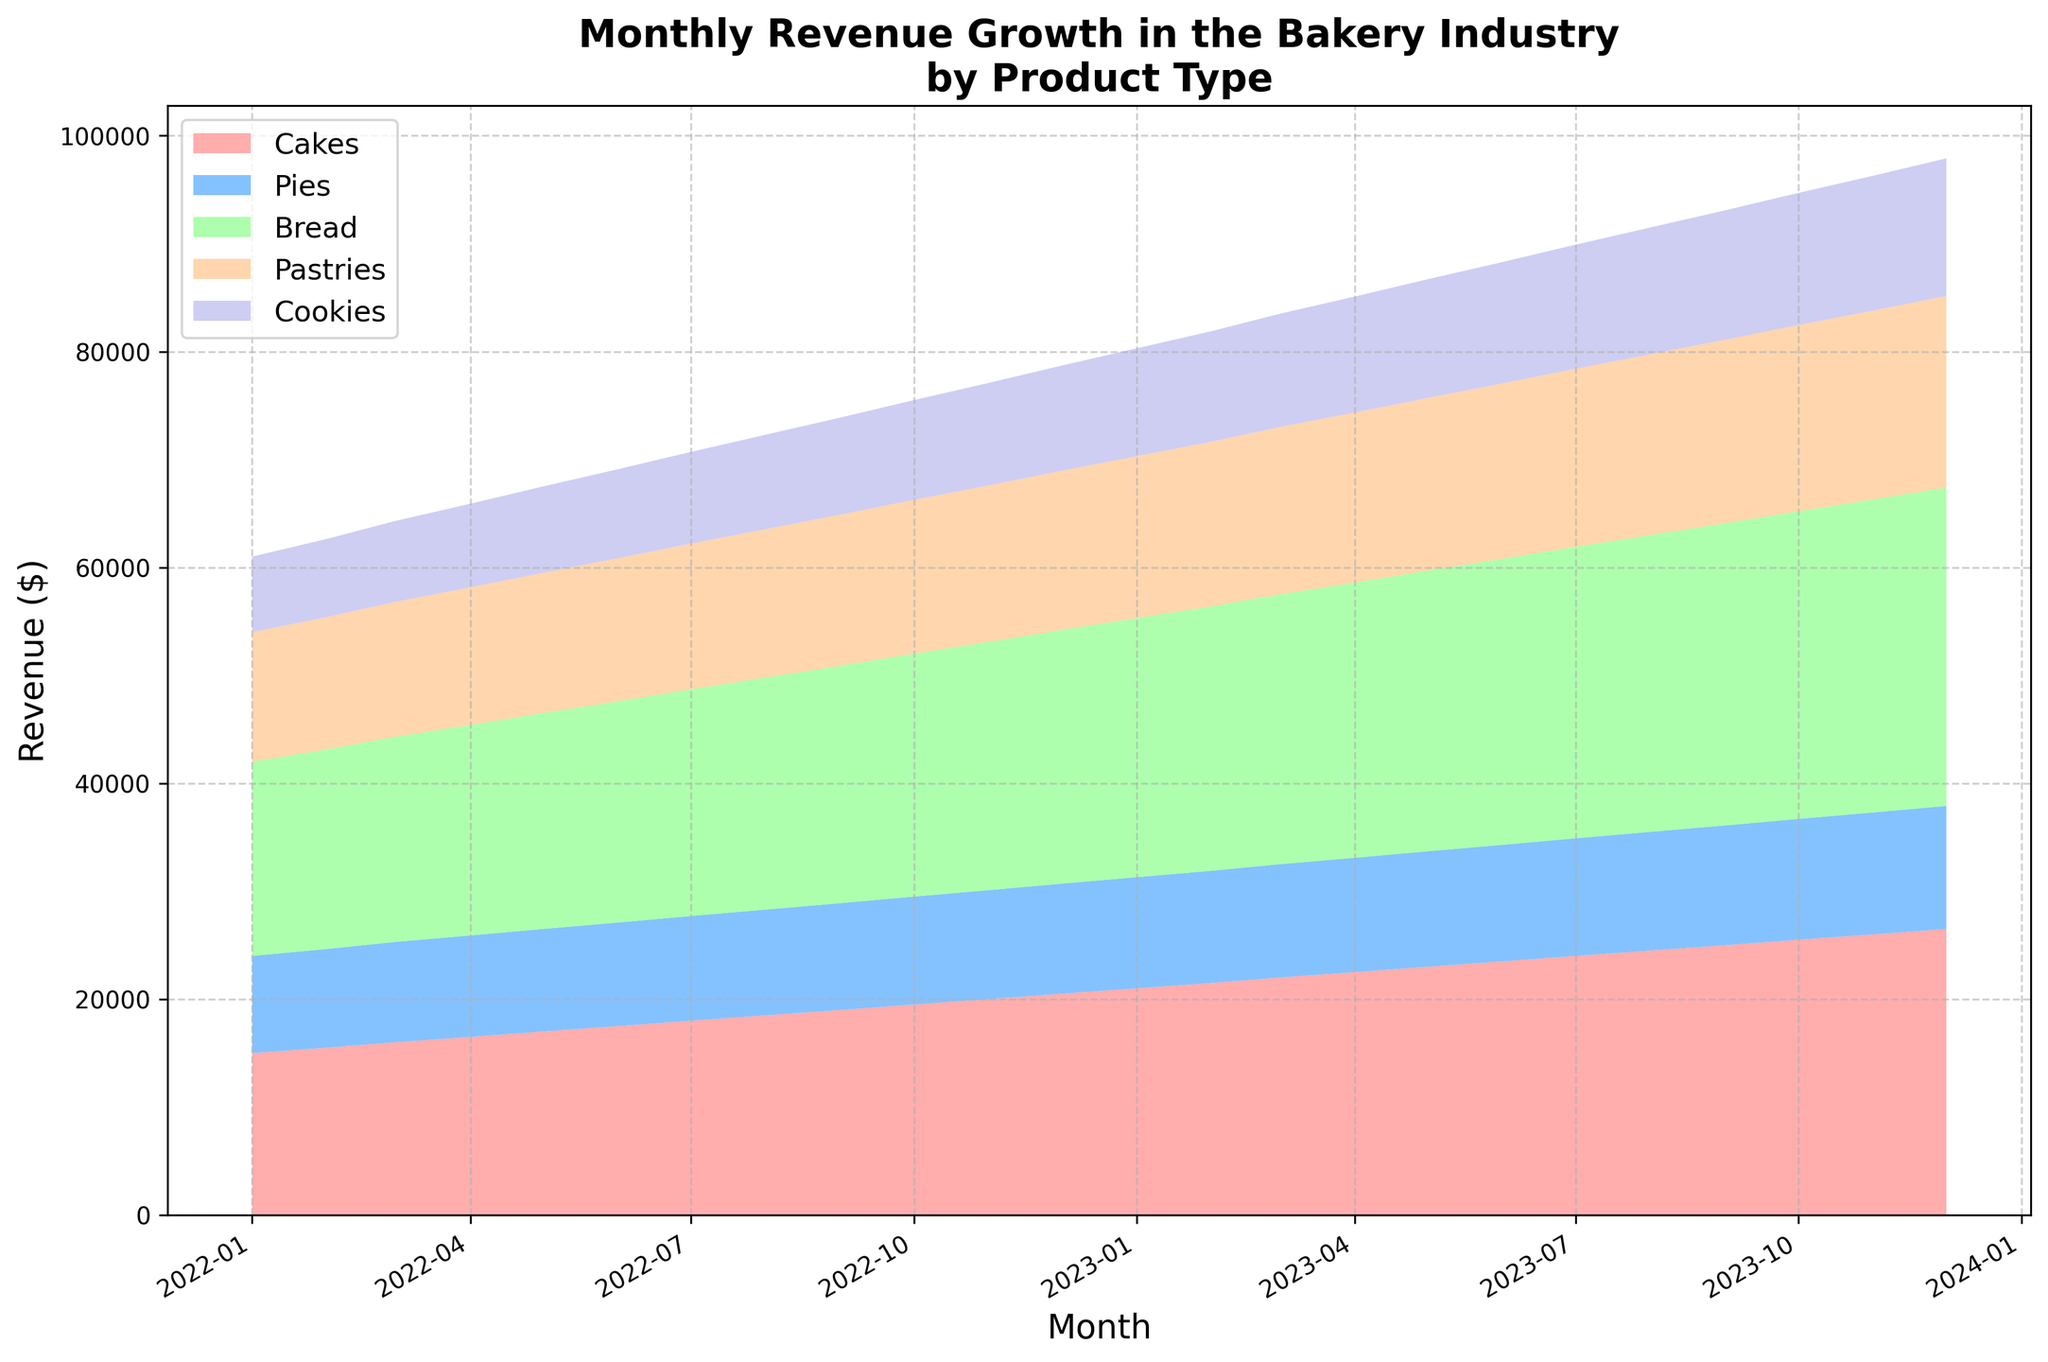What is the total revenue for October 2023? To get the total revenue, sum the revenues of all product types in October 2023: Cakes ($25,500) + Pies ($11,200) + Bread ($28,500) + Pastries ($17,250) + Cookies ($12,250) = $94,700
Answer: $94,700 Which product type had the highest revenue in January 2022? Observe the heights of the different colored areas in January 2022. Bread shows the highest revenue at $18,000, as it has the tallest segment in the stack plot.
Answer: Bread How much did the revenue from Pastries increase from January 2022 to December 2023? Subtract the revenue of Pastries in January 2022 ($12,000) from the revenue in December 2023 ($17,750): $17,750 - $12,000 = $5,750.
Answer: $5,750 In which month did Bread surpass the $20,000 revenue mark for the first time? Track the Bread segment in the stacked area chart and see when it first goes beyond the $20,000 mark. It happens in July 2022.
Answer: July 2022 What is the average revenue of Cakes in the year 2022? Add the monthly revenues of Cakes in 2022 and divide by 12: ($15,000 + $15,500 + $16,000 + $16,500 + $17,000 + $17,500 + $18,000 + $18,500 + $19,000 + $19,500 + $20,000 + $20,500) / 12 = $17,750.
Answer: $17,750 Which month had the highest combined revenue, and what was it? Sum the revenues of all product types for each month and compare. December 2023 had the highest combined revenue with a total of $96,600.
Answer: December 2023, $96,600 Between August 2022 and August 2023, which product type had the smallest revenue growth? Calculate the difference in revenue for each product type between August 2022 and August 2023 and identify the smallest: Cakes: $6,000, Pies: $1,200, Bread: $6,000, Pastries: $3,000, Cookies: $3,000. The smallest growth is in Pies: $1,200.
Answer: Pies By what percentage did Cookies' revenue increase from January 2022 to January 2023? Calculate the percentage change: ((Revenue in January 2023 - Revenue in January 2022) / Revenue in January 2022) * 100 = (($10,000 - $7,000) / $7,000) * 100 ≈ 42.86%.
Answer: 42.86% How does the revenue trend for Pies compare to that of Pastries from January 2022 to December 2023? Examine the slope of the segments representing Pies and Pastries over the time period. Both show steady increases, but Pastries have a steeper increase than Pies consistently throughout the period.
Answer: Pastries have a steeper increase In which months did Cookies' revenue surpass $10,000? Track the Cookies segment in the stacked area chart and note the months when it goes beyond the $10,000 mark. It happens in January 2023 and continues through December 2023.
Answer: January 2023 to December 2023 